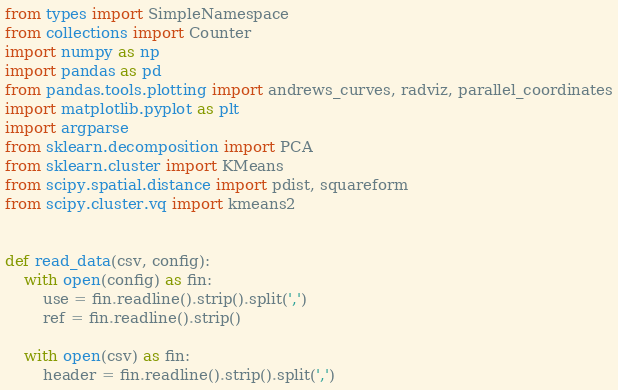<code> <loc_0><loc_0><loc_500><loc_500><_Python_>from types import SimpleNamespace
from collections import Counter
import numpy as np
import pandas as pd
from pandas.tools.plotting import andrews_curves, radviz, parallel_coordinates
import matplotlib.pyplot as plt
import argparse
from sklearn.decomposition import PCA
from sklearn.cluster import KMeans
from scipy.spatial.distance import pdist, squareform
from scipy.cluster.vq import kmeans2


def read_data(csv, config):
    with open(config) as fin:
        use = fin.readline().strip().split(',')
        ref = fin.readline().strip()

    with open(csv) as fin:
        header = fin.readline().strip().split(',')</code> 